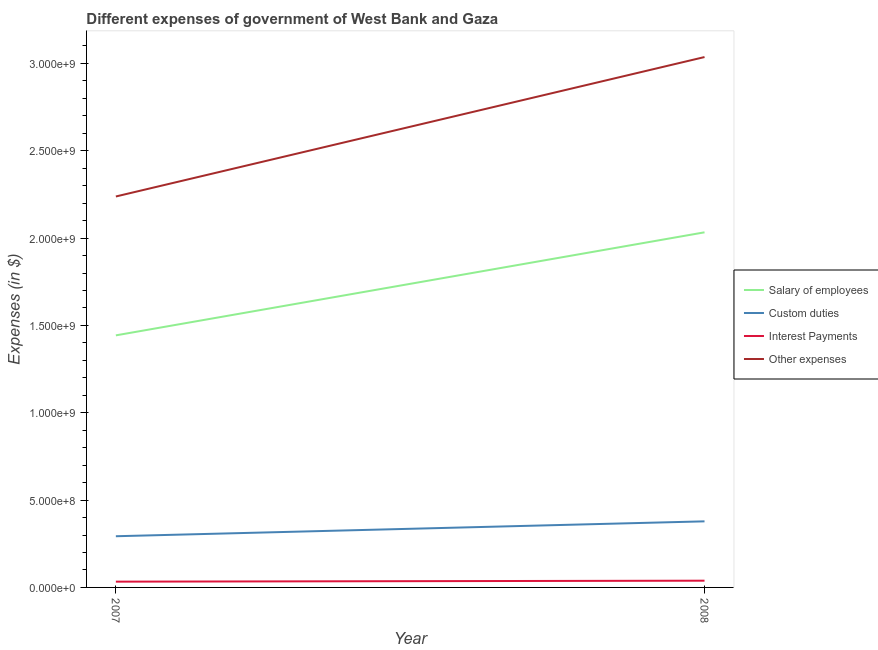Does the line corresponding to amount spent on other expenses intersect with the line corresponding to amount spent on custom duties?
Your answer should be compact. No. Is the number of lines equal to the number of legend labels?
Your answer should be very brief. Yes. What is the amount spent on salary of employees in 2007?
Give a very brief answer. 1.44e+09. Across all years, what is the maximum amount spent on salary of employees?
Keep it short and to the point. 2.03e+09. Across all years, what is the minimum amount spent on custom duties?
Ensure brevity in your answer.  2.93e+08. In which year was the amount spent on salary of employees maximum?
Offer a terse response. 2008. What is the total amount spent on interest payments in the graph?
Your response must be concise. 7.16e+07. What is the difference between the amount spent on custom duties in 2007 and that in 2008?
Ensure brevity in your answer.  -8.53e+07. What is the difference between the amount spent on custom duties in 2007 and the amount spent on salary of employees in 2008?
Offer a terse response. -1.74e+09. What is the average amount spent on interest payments per year?
Ensure brevity in your answer.  3.58e+07. In the year 2007, what is the difference between the amount spent on other expenses and amount spent on custom duties?
Your answer should be compact. 1.94e+09. In how many years, is the amount spent on custom duties greater than 2500000000 $?
Give a very brief answer. 0. What is the ratio of the amount spent on custom duties in 2007 to that in 2008?
Give a very brief answer. 0.77. Is it the case that in every year, the sum of the amount spent on custom duties and amount spent on other expenses is greater than the sum of amount spent on interest payments and amount spent on salary of employees?
Provide a succinct answer. No. Is it the case that in every year, the sum of the amount spent on salary of employees and amount spent on custom duties is greater than the amount spent on interest payments?
Provide a short and direct response. Yes. Does the amount spent on custom duties monotonically increase over the years?
Offer a terse response. Yes. Is the amount spent on custom duties strictly less than the amount spent on salary of employees over the years?
Offer a terse response. Yes. How many years are there in the graph?
Make the answer very short. 2. What is the difference between two consecutive major ticks on the Y-axis?
Provide a short and direct response. 5.00e+08. Are the values on the major ticks of Y-axis written in scientific E-notation?
Provide a short and direct response. Yes. Where does the legend appear in the graph?
Offer a very short reply. Center right. How are the legend labels stacked?
Your response must be concise. Vertical. What is the title of the graph?
Keep it short and to the point. Different expenses of government of West Bank and Gaza. Does "European Union" appear as one of the legend labels in the graph?
Give a very brief answer. No. What is the label or title of the Y-axis?
Your answer should be compact. Expenses (in $). What is the Expenses (in $) in Salary of employees in 2007?
Ensure brevity in your answer.  1.44e+09. What is the Expenses (in $) in Custom duties in 2007?
Make the answer very short. 2.93e+08. What is the Expenses (in $) of Interest Payments in 2007?
Provide a succinct answer. 3.30e+07. What is the Expenses (in $) of Other expenses in 2007?
Give a very brief answer. 2.24e+09. What is the Expenses (in $) in Salary of employees in 2008?
Your response must be concise. 2.03e+09. What is the Expenses (in $) of Custom duties in 2008?
Provide a succinct answer. 3.78e+08. What is the Expenses (in $) of Interest Payments in 2008?
Your answer should be compact. 3.86e+07. What is the Expenses (in $) in Other expenses in 2008?
Your answer should be compact. 3.04e+09. Across all years, what is the maximum Expenses (in $) of Salary of employees?
Your answer should be very brief. 2.03e+09. Across all years, what is the maximum Expenses (in $) in Custom duties?
Keep it short and to the point. 3.78e+08. Across all years, what is the maximum Expenses (in $) of Interest Payments?
Provide a short and direct response. 3.86e+07. Across all years, what is the maximum Expenses (in $) of Other expenses?
Make the answer very short. 3.04e+09. Across all years, what is the minimum Expenses (in $) of Salary of employees?
Your answer should be very brief. 1.44e+09. Across all years, what is the minimum Expenses (in $) of Custom duties?
Give a very brief answer. 2.93e+08. Across all years, what is the minimum Expenses (in $) of Interest Payments?
Offer a very short reply. 3.30e+07. Across all years, what is the minimum Expenses (in $) of Other expenses?
Your response must be concise. 2.24e+09. What is the total Expenses (in $) in Salary of employees in the graph?
Offer a very short reply. 3.48e+09. What is the total Expenses (in $) in Custom duties in the graph?
Make the answer very short. 6.71e+08. What is the total Expenses (in $) of Interest Payments in the graph?
Ensure brevity in your answer.  7.16e+07. What is the total Expenses (in $) in Other expenses in the graph?
Your answer should be compact. 5.27e+09. What is the difference between the Expenses (in $) in Salary of employees in 2007 and that in 2008?
Offer a very short reply. -5.90e+08. What is the difference between the Expenses (in $) in Custom duties in 2007 and that in 2008?
Offer a very short reply. -8.53e+07. What is the difference between the Expenses (in $) in Interest Payments in 2007 and that in 2008?
Offer a very short reply. -5.57e+06. What is the difference between the Expenses (in $) in Other expenses in 2007 and that in 2008?
Your response must be concise. -7.98e+08. What is the difference between the Expenses (in $) in Salary of employees in 2007 and the Expenses (in $) in Custom duties in 2008?
Your response must be concise. 1.06e+09. What is the difference between the Expenses (in $) of Salary of employees in 2007 and the Expenses (in $) of Interest Payments in 2008?
Make the answer very short. 1.40e+09. What is the difference between the Expenses (in $) in Salary of employees in 2007 and the Expenses (in $) in Other expenses in 2008?
Your answer should be compact. -1.59e+09. What is the difference between the Expenses (in $) in Custom duties in 2007 and the Expenses (in $) in Interest Payments in 2008?
Offer a terse response. 2.54e+08. What is the difference between the Expenses (in $) in Custom duties in 2007 and the Expenses (in $) in Other expenses in 2008?
Ensure brevity in your answer.  -2.74e+09. What is the difference between the Expenses (in $) of Interest Payments in 2007 and the Expenses (in $) of Other expenses in 2008?
Make the answer very short. -3.00e+09. What is the average Expenses (in $) in Salary of employees per year?
Ensure brevity in your answer.  1.74e+09. What is the average Expenses (in $) of Custom duties per year?
Offer a terse response. 3.36e+08. What is the average Expenses (in $) of Interest Payments per year?
Give a very brief answer. 3.58e+07. What is the average Expenses (in $) of Other expenses per year?
Your response must be concise. 2.64e+09. In the year 2007, what is the difference between the Expenses (in $) in Salary of employees and Expenses (in $) in Custom duties?
Provide a succinct answer. 1.15e+09. In the year 2007, what is the difference between the Expenses (in $) in Salary of employees and Expenses (in $) in Interest Payments?
Make the answer very short. 1.41e+09. In the year 2007, what is the difference between the Expenses (in $) in Salary of employees and Expenses (in $) in Other expenses?
Provide a short and direct response. -7.95e+08. In the year 2007, what is the difference between the Expenses (in $) in Custom duties and Expenses (in $) in Interest Payments?
Offer a terse response. 2.60e+08. In the year 2007, what is the difference between the Expenses (in $) in Custom duties and Expenses (in $) in Other expenses?
Provide a succinct answer. -1.94e+09. In the year 2007, what is the difference between the Expenses (in $) in Interest Payments and Expenses (in $) in Other expenses?
Offer a terse response. -2.20e+09. In the year 2008, what is the difference between the Expenses (in $) of Salary of employees and Expenses (in $) of Custom duties?
Ensure brevity in your answer.  1.65e+09. In the year 2008, what is the difference between the Expenses (in $) of Salary of employees and Expenses (in $) of Interest Payments?
Your response must be concise. 1.99e+09. In the year 2008, what is the difference between the Expenses (in $) in Salary of employees and Expenses (in $) in Other expenses?
Offer a terse response. -1.00e+09. In the year 2008, what is the difference between the Expenses (in $) of Custom duties and Expenses (in $) of Interest Payments?
Your response must be concise. 3.40e+08. In the year 2008, what is the difference between the Expenses (in $) of Custom duties and Expenses (in $) of Other expenses?
Your answer should be compact. -2.66e+09. In the year 2008, what is the difference between the Expenses (in $) of Interest Payments and Expenses (in $) of Other expenses?
Provide a short and direct response. -3.00e+09. What is the ratio of the Expenses (in $) of Salary of employees in 2007 to that in 2008?
Your answer should be very brief. 0.71. What is the ratio of the Expenses (in $) of Custom duties in 2007 to that in 2008?
Your answer should be very brief. 0.77. What is the ratio of the Expenses (in $) of Interest Payments in 2007 to that in 2008?
Your answer should be compact. 0.86. What is the ratio of the Expenses (in $) of Other expenses in 2007 to that in 2008?
Offer a terse response. 0.74. What is the difference between the highest and the second highest Expenses (in $) in Salary of employees?
Offer a very short reply. 5.90e+08. What is the difference between the highest and the second highest Expenses (in $) of Custom duties?
Provide a short and direct response. 8.53e+07. What is the difference between the highest and the second highest Expenses (in $) of Interest Payments?
Provide a succinct answer. 5.57e+06. What is the difference between the highest and the second highest Expenses (in $) of Other expenses?
Your answer should be very brief. 7.98e+08. What is the difference between the highest and the lowest Expenses (in $) in Salary of employees?
Offer a terse response. 5.90e+08. What is the difference between the highest and the lowest Expenses (in $) of Custom duties?
Offer a terse response. 8.53e+07. What is the difference between the highest and the lowest Expenses (in $) of Interest Payments?
Your response must be concise. 5.57e+06. What is the difference between the highest and the lowest Expenses (in $) in Other expenses?
Your response must be concise. 7.98e+08. 